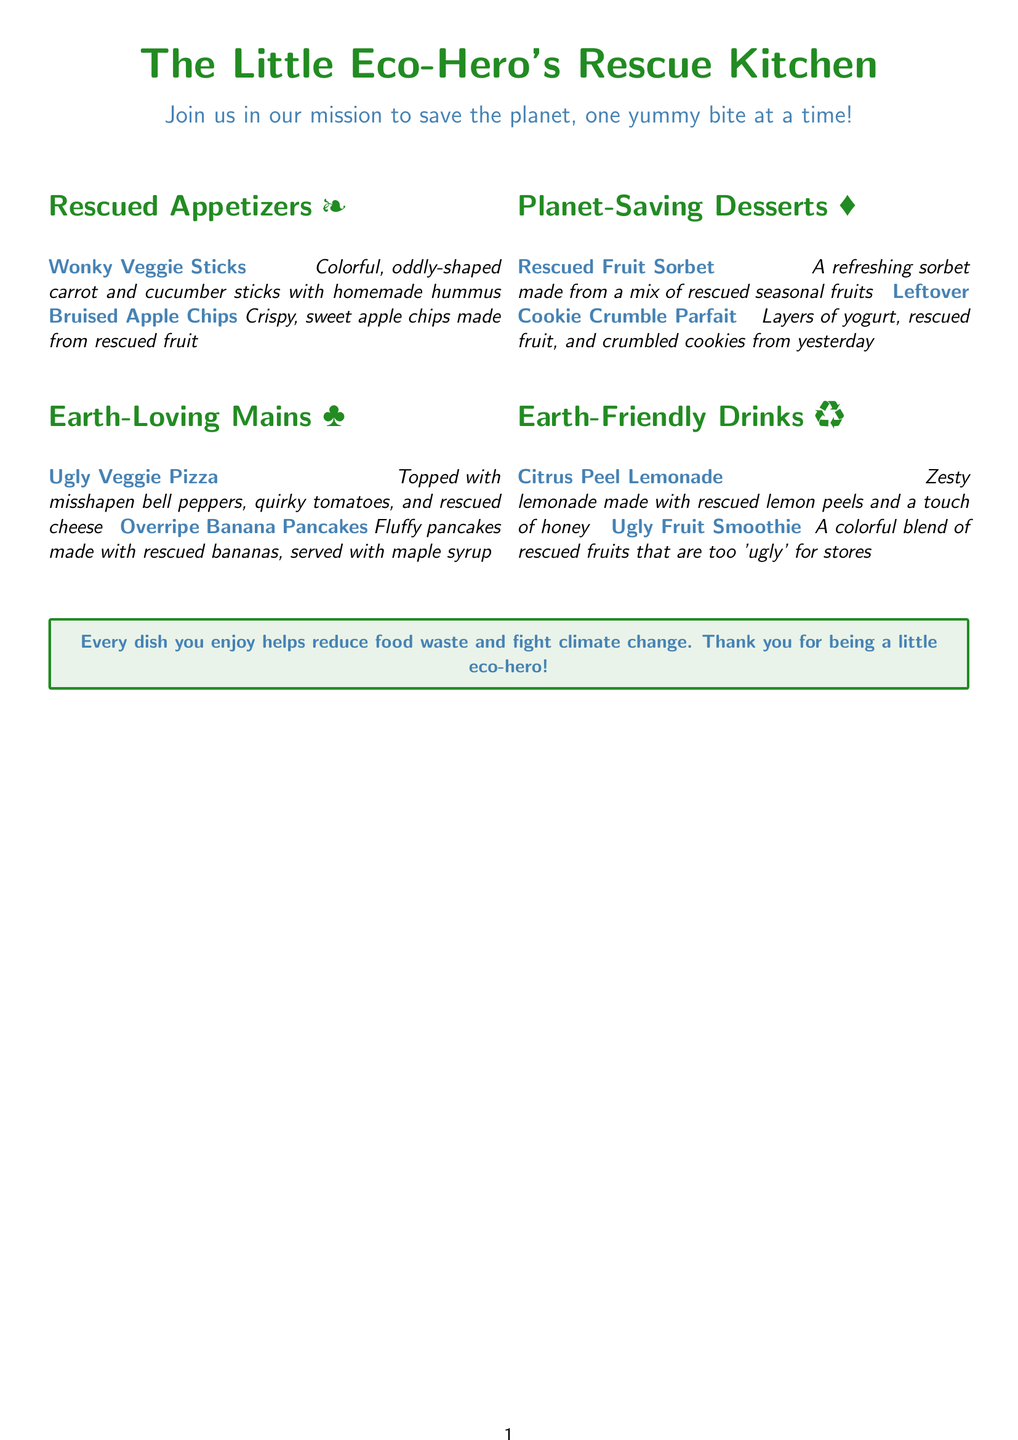What are the appetizers called? The appetizers listed in the menu are categorized under "Rescued Appetizers."
Answer: Rescued Appetizers How many mains are listed on the menu? There are two main dishes listed under "Earth-Loving Mains."
Answer: Two What is made from rescued bananas? The main dish that includes rescued bananas is clearly mentioned in the menu.
Answer: Overripe Banana Pancakes What dessert uses rescued fruits? The dessert that specifically mentions using rescued fruits is found in the "Planet-Saving Desserts" section.
Answer: Rescued Fruit Sorbet What color are the wonky veggie sticks? The wonky veggie sticks are described with colors of the ingredients used.
Answer: Colorful Which dish helps reduce food waste? The menu notes that all dishes contribute to reducing food waste, but one specific item is highlighted for this.
Answer: Every dish What drink is made with rescued lemon peels? The drink made with rescued lemon peels is found in the "Earth-Friendly Drinks" section.
Answer: Citrus Peel Lemonade What is the theme of the restaurant? The menu emphasizes the mission of the restaurant and its commitment to environmental issues.
Answer: Save the planet What type of smoothie is featured? One specific type of smoothie is mentioned that uses imperfect produce.
Answer: Ugly Fruit Smoothie 